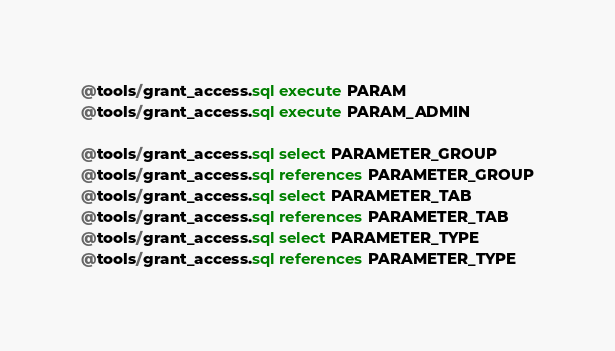<code> <loc_0><loc_0><loc_500><loc_500><_SQL_>@tools/grant_access.sql execute PARAM
@tools/grant_access.sql execute PARAM_ADMIN

@tools/grant_access.sql select PARAMETER_GROUP
@tools/grant_access.sql references PARAMETER_GROUP
@tools/grant_access.sql select PARAMETER_TAB
@tools/grant_access.sql references PARAMETER_TAB
@tools/grant_access.sql select PARAMETER_TYPE
@tools/grant_access.sql references PARAMETER_TYPE
</code> 